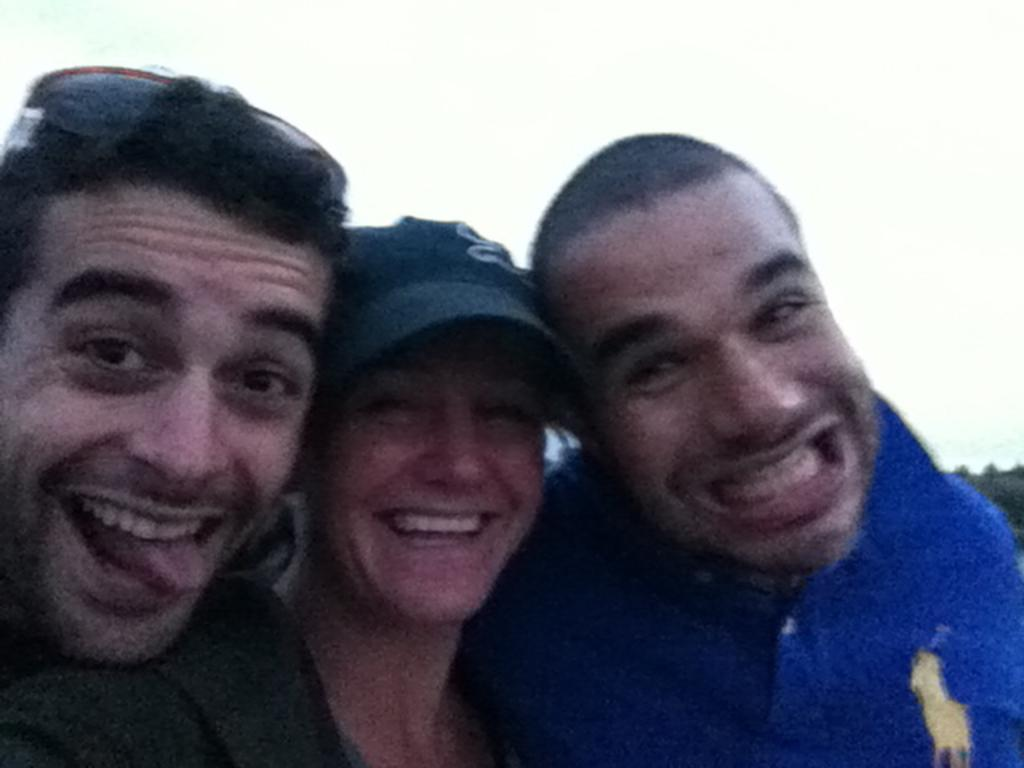Who or what can be seen in the image? There are people in the image. Where are the people located in the image? The people are in the center of the image. What type of cat can be seen playing in the field in the image? There is no cat or field present in the image; it only features people in the center. 